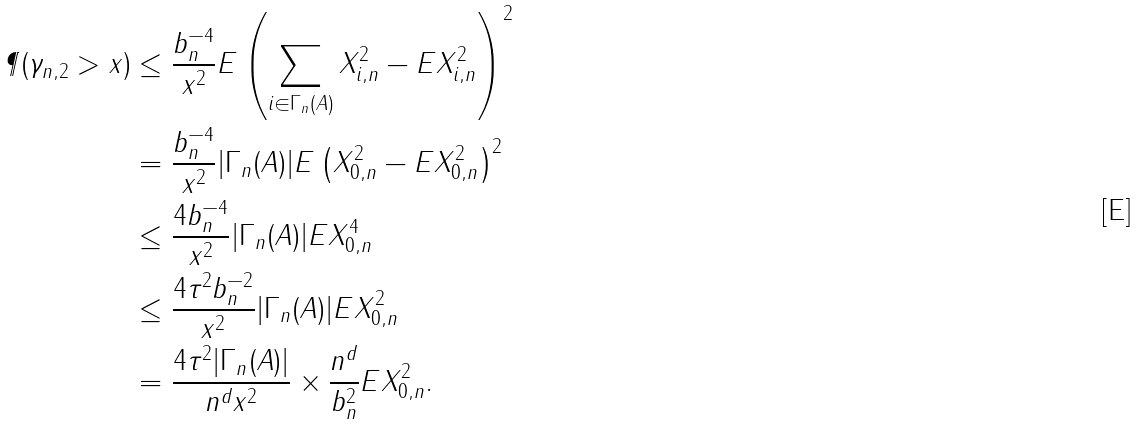Convert formula to latex. <formula><loc_0><loc_0><loc_500><loc_500>\P ( \gamma _ { n , 2 } > x ) & \leq \frac { b _ { n } ^ { - 4 } } { x ^ { 2 } } E \left ( \sum _ { i \in \Gamma _ { n } ( A ) } X _ { i , n } ^ { 2 } - E X _ { i , n } ^ { 2 } \right ) ^ { 2 } \\ & = \frac { b _ { n } ^ { - 4 } } { x ^ { 2 } } | \Gamma _ { n } ( A ) | E \left ( X _ { 0 , n } ^ { 2 } - E X _ { 0 , n } ^ { 2 } \right ) ^ { 2 } \\ & \leq \frac { 4 b _ { n } ^ { - 4 } } { x ^ { 2 } } | \Gamma _ { n } ( A ) | E X _ { 0 , n } ^ { 4 } \\ & \leq \frac { 4 \tau ^ { 2 } b _ { n } ^ { - 2 } } { x ^ { 2 } } | \Gamma _ { n } ( A ) | E X _ { 0 , n } ^ { 2 } \\ & = \frac { 4 \tau ^ { 2 } | \Gamma _ { n } ( A ) | } { n ^ { d } x ^ { 2 } } \times \frac { n ^ { d } } { b _ { n } ^ { 2 } } E X _ { 0 , n } ^ { 2 } .</formula> 